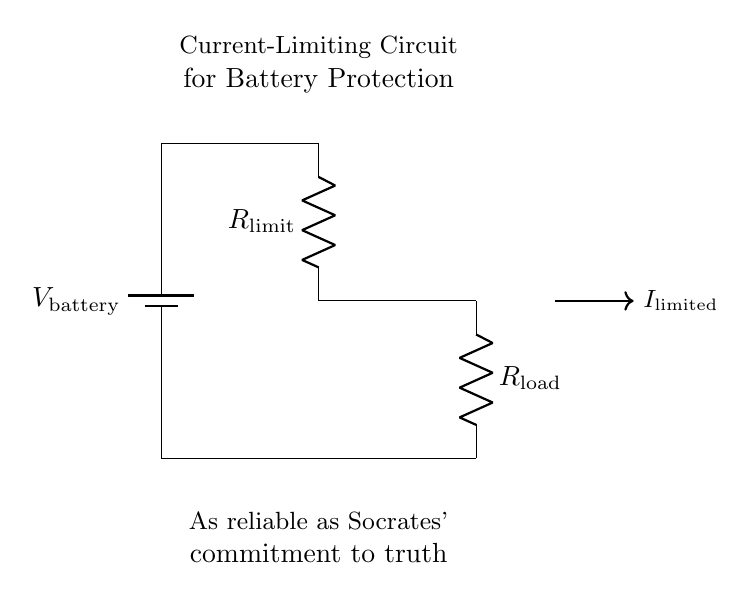What source powers this circuit? The source powering the circuit is indicated as a battery, labeled as V battery at the top.
Answer: battery What is the purpose of R limit? R limit is labeled as the current-limiting resistor, which reduces the current flow to protect the battery from overcurrent.
Answer: current-limiting What does R load represent in the circuit? R load is another resistor in the circuit that represents the load connected to the battery, taking current from it using a certain resistance value.
Answer: load What does the arrow next to I limited signify? The arrow indicates the direction of the limited current, showing that it flows from the battery through the circuit after being constrained by the resistors.
Answer: current direction How is the circuit related to battery protection? The circuit limits current flow to protect the battery, thereby preventing potential damage due to excessive current, making it a form of battery protection circuit.
Answer: battery protection What type of circuit is depicted here? The circuit is a simple current-limiting circuit, which incorporates resistors to limit the amount of current drawn from the battery for safety purposes.
Answer: current-limiting circuit 